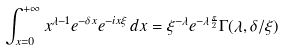<formula> <loc_0><loc_0><loc_500><loc_500>\int _ { x = 0 } ^ { + \infty } x ^ { \lambda - 1 } e ^ { - \delta x } e ^ { - i x \xi } \, d x = \xi ^ { - \lambda } e ^ { - \lambda \frac { \pi } { 2 } } \Gamma ( \lambda , \delta / \xi )</formula> 